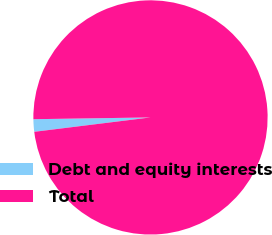<chart> <loc_0><loc_0><loc_500><loc_500><pie_chart><fcel>Debt and equity interests<fcel>Total<nl><fcel>1.72%<fcel>98.28%<nl></chart> 